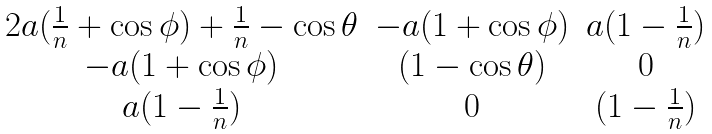Convert formula to latex. <formula><loc_0><loc_0><loc_500><loc_500>\begin{matrix} 2 a ( \frac { 1 } { n } + \cos \phi ) + \frac { 1 } { n } - \cos \theta & - a ( 1 + \cos \phi ) & a ( 1 - \frac { 1 } { n } ) \\ - a ( 1 + \cos \phi ) & ( 1 - \cos \theta ) & 0 \\ a ( 1 - \frac { 1 } { n } ) & 0 & ( 1 - \frac { 1 } { n } ) \end{matrix}</formula> 